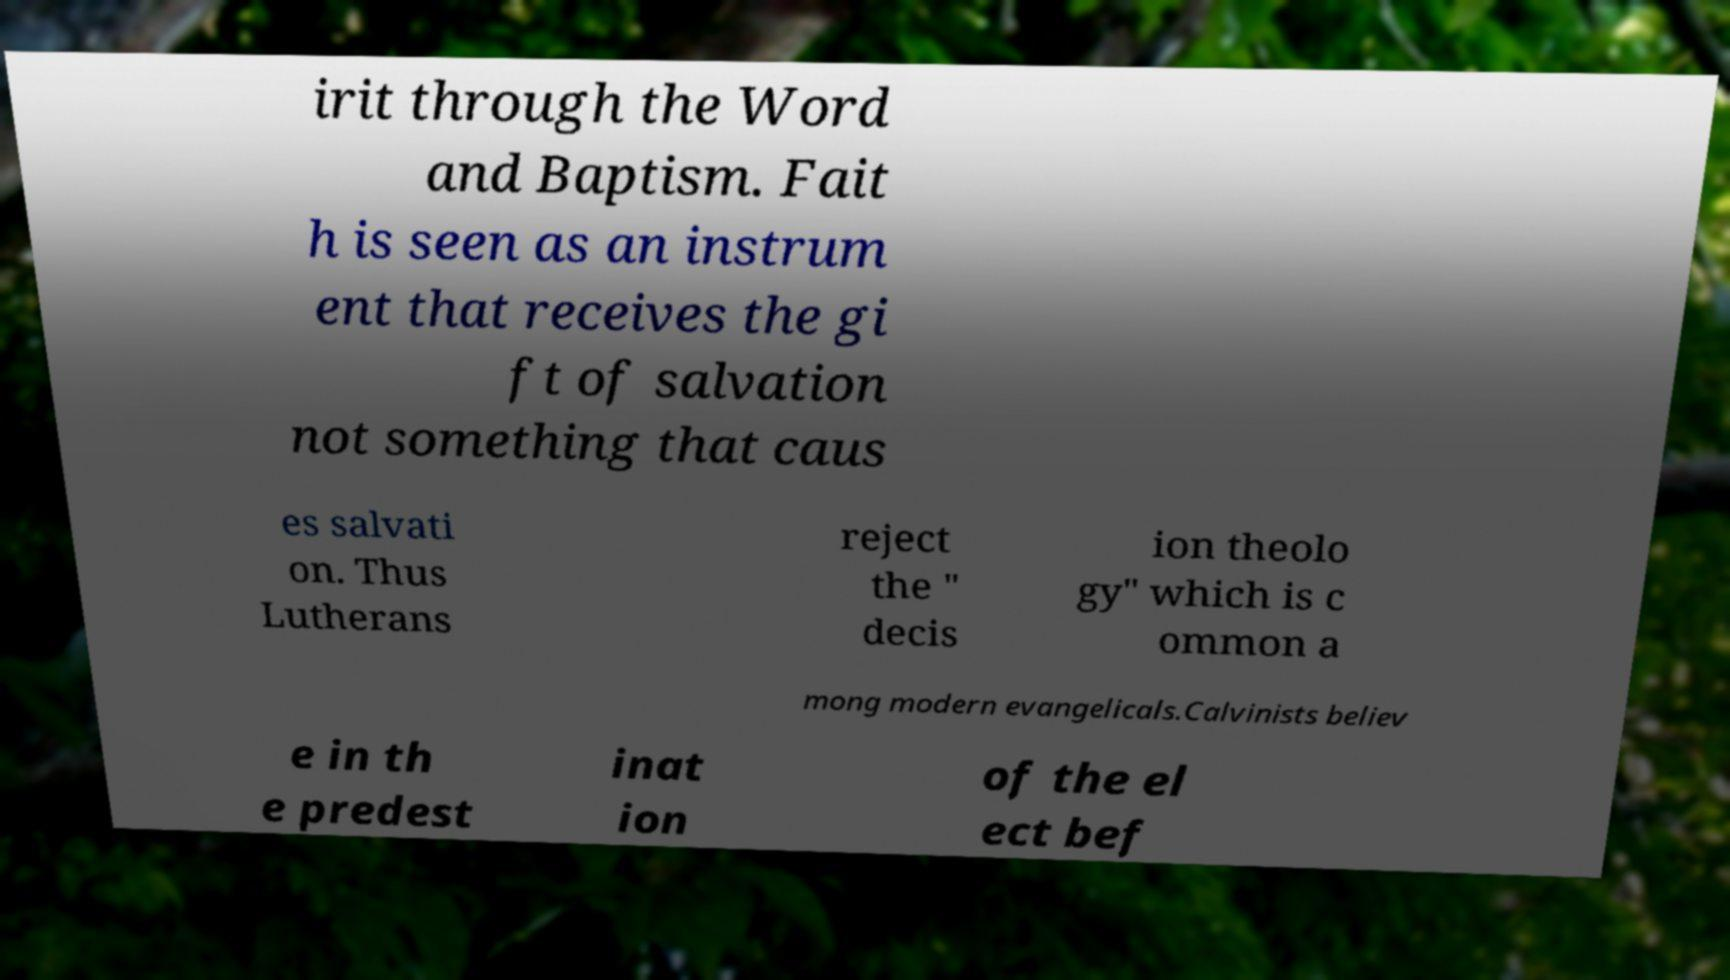There's text embedded in this image that I need extracted. Can you transcribe it verbatim? irit through the Word and Baptism. Fait h is seen as an instrum ent that receives the gi ft of salvation not something that caus es salvati on. Thus Lutherans reject the " decis ion theolo gy" which is c ommon a mong modern evangelicals.Calvinists believ e in th e predest inat ion of the el ect bef 